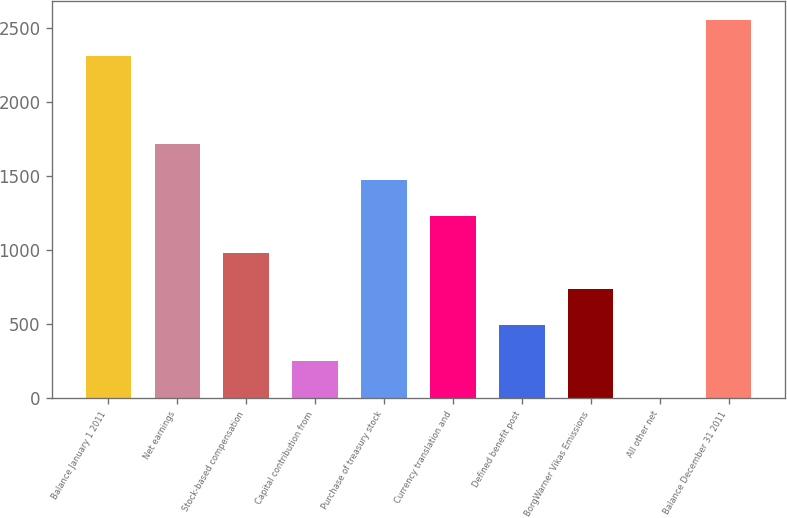Convert chart. <chart><loc_0><loc_0><loc_500><loc_500><bar_chart><fcel>Balance January 1 2011<fcel>Net earnings<fcel>Stock-based compensation<fcel>Capital contribution from<fcel>Purchase of treasury stock<fcel>Currency translation and<fcel>Defined benefit post<fcel>BorgWarner Vikas Emissions<fcel>All other net<fcel>Balance December 31 2011<nl><fcel>2309.8<fcel>1718.18<fcel>983.36<fcel>248.54<fcel>1473.24<fcel>1228.3<fcel>493.48<fcel>738.42<fcel>3.6<fcel>2554.74<nl></chart> 